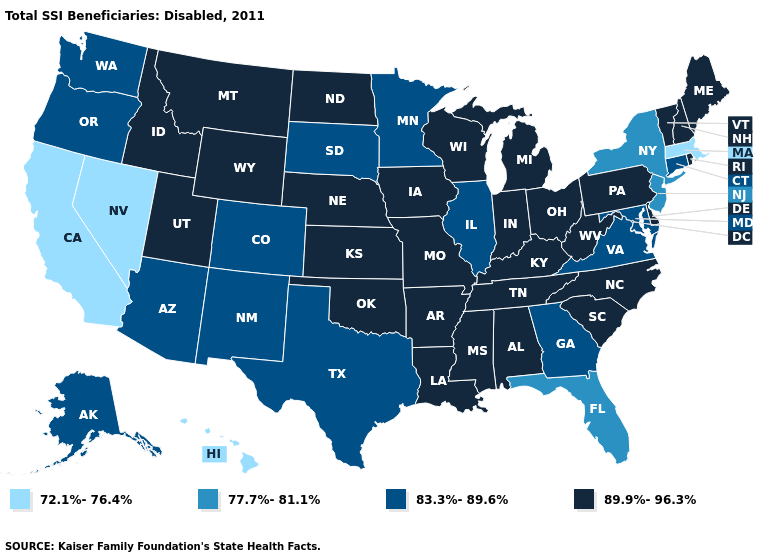What is the value of Massachusetts?
Be succinct. 72.1%-76.4%. What is the value of California?
Give a very brief answer. 72.1%-76.4%. Name the states that have a value in the range 72.1%-76.4%?
Short answer required. California, Hawaii, Massachusetts, Nevada. What is the value of Georgia?
Short answer required. 83.3%-89.6%. What is the highest value in the USA?
Write a very short answer. 89.9%-96.3%. Does New Mexico have a higher value than Hawaii?
Be succinct. Yes. Name the states that have a value in the range 89.9%-96.3%?
Write a very short answer. Alabama, Arkansas, Delaware, Idaho, Indiana, Iowa, Kansas, Kentucky, Louisiana, Maine, Michigan, Mississippi, Missouri, Montana, Nebraska, New Hampshire, North Carolina, North Dakota, Ohio, Oklahoma, Pennsylvania, Rhode Island, South Carolina, Tennessee, Utah, Vermont, West Virginia, Wisconsin, Wyoming. What is the value of Georgia?
Quick response, please. 83.3%-89.6%. What is the value of Washington?
Quick response, please. 83.3%-89.6%. Is the legend a continuous bar?
Short answer required. No. Does New York have the highest value in the USA?
Write a very short answer. No. Name the states that have a value in the range 89.9%-96.3%?
Quick response, please. Alabama, Arkansas, Delaware, Idaho, Indiana, Iowa, Kansas, Kentucky, Louisiana, Maine, Michigan, Mississippi, Missouri, Montana, Nebraska, New Hampshire, North Carolina, North Dakota, Ohio, Oklahoma, Pennsylvania, Rhode Island, South Carolina, Tennessee, Utah, Vermont, West Virginia, Wisconsin, Wyoming. What is the value of Kentucky?
Give a very brief answer. 89.9%-96.3%. What is the value of Colorado?
Be succinct. 83.3%-89.6%. 